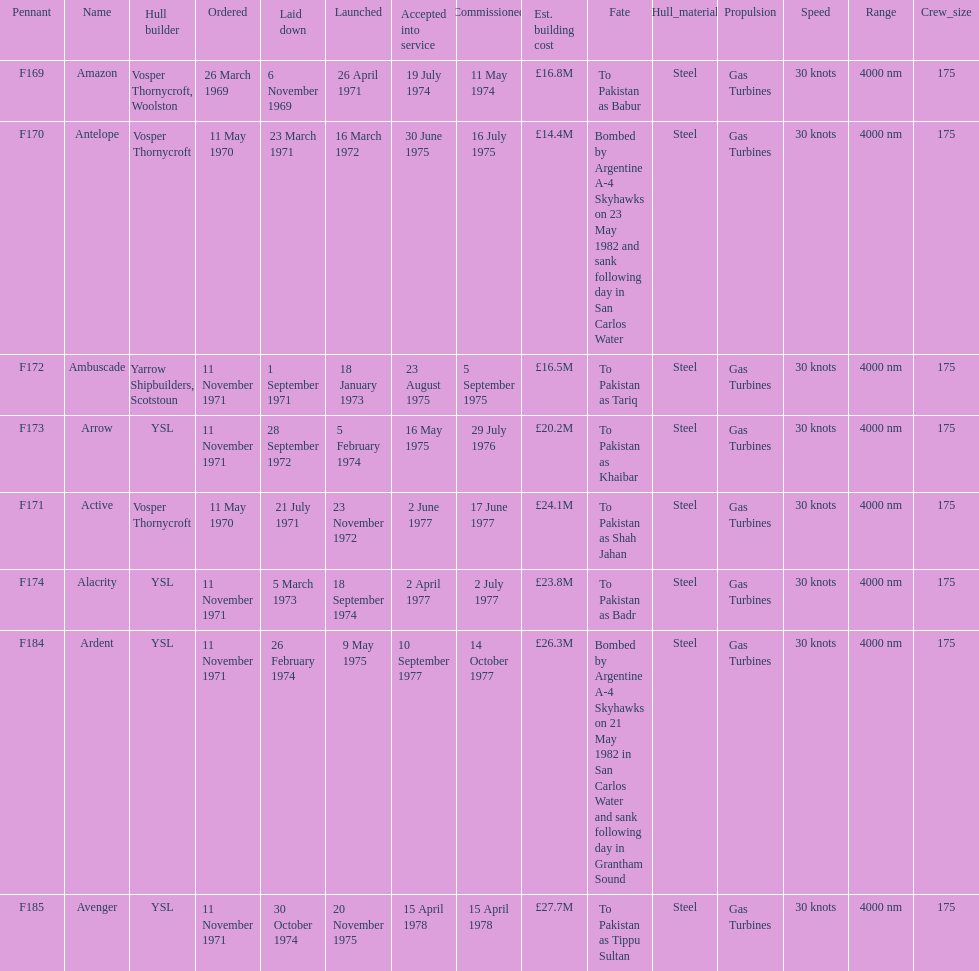Tell me the number of ships that went to pakistan. 6. 